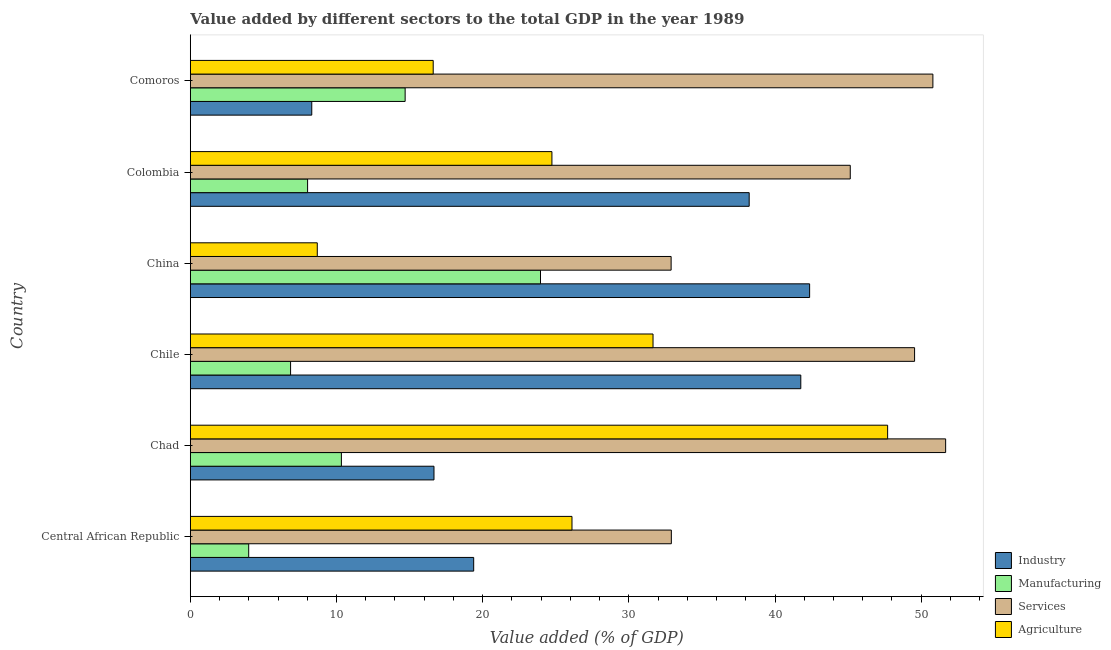How many different coloured bars are there?
Make the answer very short. 4. How many bars are there on the 4th tick from the top?
Offer a terse response. 4. What is the label of the 6th group of bars from the top?
Give a very brief answer. Central African Republic. What is the value added by manufacturing sector in China?
Give a very brief answer. 23.96. Across all countries, what is the maximum value added by services sector?
Keep it short and to the point. 51.67. Across all countries, what is the minimum value added by manufacturing sector?
Offer a very short reply. 4. In which country was the value added by services sector maximum?
Keep it short and to the point. Chad. In which country was the value added by industrial sector minimum?
Offer a terse response. Comoros. What is the total value added by industrial sector in the graph?
Offer a very short reply. 166.73. What is the difference between the value added by manufacturing sector in Chad and that in Chile?
Give a very brief answer. 3.48. What is the difference between the value added by industrial sector in Central African Republic and the value added by agricultural sector in Chad?
Make the answer very short. -28.32. What is the average value added by manufacturing sector per country?
Offer a terse response. 11.31. What is the difference between the value added by manufacturing sector and value added by industrial sector in Colombia?
Provide a short and direct response. -30.21. What is the ratio of the value added by manufacturing sector in Chile to that in China?
Ensure brevity in your answer.  0.29. Is the value added by services sector in Chile less than that in China?
Offer a terse response. No. What is the difference between the highest and the second highest value added by agricultural sector?
Give a very brief answer. 16.05. What is the difference between the highest and the lowest value added by industrial sector?
Make the answer very short. 34.06. In how many countries, is the value added by industrial sector greater than the average value added by industrial sector taken over all countries?
Offer a very short reply. 3. Is the sum of the value added by manufacturing sector in China and Colombia greater than the maximum value added by agricultural sector across all countries?
Make the answer very short. No. What does the 2nd bar from the top in Chile represents?
Your response must be concise. Services. What does the 2nd bar from the bottom in Chad represents?
Offer a terse response. Manufacturing. Is it the case that in every country, the sum of the value added by industrial sector and value added by manufacturing sector is greater than the value added by services sector?
Make the answer very short. No. What is the difference between two consecutive major ticks on the X-axis?
Your answer should be compact. 10. Are the values on the major ticks of X-axis written in scientific E-notation?
Your response must be concise. No. Does the graph contain grids?
Your answer should be compact. No. Where does the legend appear in the graph?
Ensure brevity in your answer.  Bottom right. What is the title of the graph?
Provide a succinct answer. Value added by different sectors to the total GDP in the year 1989. Does "Services" appear as one of the legend labels in the graph?
Offer a very short reply. Yes. What is the label or title of the X-axis?
Give a very brief answer. Value added (% of GDP). What is the label or title of the Y-axis?
Ensure brevity in your answer.  Country. What is the Value added (% of GDP) of Industry in Central African Republic?
Make the answer very short. 19.39. What is the Value added (% of GDP) of Manufacturing in Central African Republic?
Provide a short and direct response. 4. What is the Value added (% of GDP) in Services in Central African Republic?
Provide a short and direct response. 32.91. What is the Value added (% of GDP) of Agriculture in Central African Republic?
Offer a terse response. 26.11. What is the Value added (% of GDP) in Industry in Chad?
Your response must be concise. 16.67. What is the Value added (% of GDP) of Manufacturing in Chad?
Offer a terse response. 10.34. What is the Value added (% of GDP) in Services in Chad?
Offer a very short reply. 51.67. What is the Value added (% of GDP) of Agriculture in Chad?
Your answer should be very brief. 47.7. What is the Value added (% of GDP) in Industry in Chile?
Your answer should be compact. 41.76. What is the Value added (% of GDP) of Manufacturing in Chile?
Your answer should be compact. 6.86. What is the Value added (% of GDP) of Services in Chile?
Ensure brevity in your answer.  49.55. What is the Value added (% of GDP) in Agriculture in Chile?
Ensure brevity in your answer.  31.66. What is the Value added (% of GDP) in Industry in China?
Provide a succinct answer. 42.37. What is the Value added (% of GDP) of Manufacturing in China?
Your answer should be compact. 23.96. What is the Value added (% of GDP) in Services in China?
Ensure brevity in your answer.  32.89. What is the Value added (% of GDP) of Agriculture in China?
Provide a succinct answer. 8.69. What is the Value added (% of GDP) of Industry in Colombia?
Offer a terse response. 38.23. What is the Value added (% of GDP) in Manufacturing in Colombia?
Give a very brief answer. 8.02. What is the Value added (% of GDP) in Services in Colombia?
Offer a terse response. 45.15. What is the Value added (% of GDP) of Agriculture in Colombia?
Your response must be concise. 24.74. What is the Value added (% of GDP) in Industry in Comoros?
Provide a short and direct response. 8.31. What is the Value added (% of GDP) of Manufacturing in Comoros?
Provide a short and direct response. 14.7. What is the Value added (% of GDP) in Services in Comoros?
Offer a terse response. 50.8. What is the Value added (% of GDP) in Agriculture in Comoros?
Make the answer very short. 16.62. Across all countries, what is the maximum Value added (% of GDP) of Industry?
Make the answer very short. 42.37. Across all countries, what is the maximum Value added (% of GDP) of Manufacturing?
Your answer should be compact. 23.96. Across all countries, what is the maximum Value added (% of GDP) of Services?
Provide a succinct answer. 51.67. Across all countries, what is the maximum Value added (% of GDP) in Agriculture?
Make the answer very short. 47.7. Across all countries, what is the minimum Value added (% of GDP) of Industry?
Offer a very short reply. 8.31. Across all countries, what is the minimum Value added (% of GDP) of Manufacturing?
Offer a very short reply. 4. Across all countries, what is the minimum Value added (% of GDP) of Services?
Your answer should be compact. 32.89. Across all countries, what is the minimum Value added (% of GDP) of Agriculture?
Offer a very short reply. 8.69. What is the total Value added (% of GDP) of Industry in the graph?
Provide a succinct answer. 166.73. What is the total Value added (% of GDP) of Manufacturing in the graph?
Offer a terse response. 67.87. What is the total Value added (% of GDP) of Services in the graph?
Your answer should be very brief. 262.97. What is the total Value added (% of GDP) in Agriculture in the graph?
Provide a succinct answer. 155.52. What is the difference between the Value added (% of GDP) of Industry in Central African Republic and that in Chad?
Make the answer very short. 2.72. What is the difference between the Value added (% of GDP) of Manufacturing in Central African Republic and that in Chad?
Ensure brevity in your answer.  -6.34. What is the difference between the Value added (% of GDP) in Services in Central African Republic and that in Chad?
Provide a short and direct response. -18.76. What is the difference between the Value added (% of GDP) in Agriculture in Central African Republic and that in Chad?
Your response must be concise. -21.59. What is the difference between the Value added (% of GDP) of Industry in Central African Republic and that in Chile?
Offer a very short reply. -22.38. What is the difference between the Value added (% of GDP) in Manufacturing in Central African Republic and that in Chile?
Give a very brief answer. -2.87. What is the difference between the Value added (% of GDP) of Services in Central African Republic and that in Chile?
Give a very brief answer. -16.64. What is the difference between the Value added (% of GDP) of Agriculture in Central African Republic and that in Chile?
Offer a very short reply. -5.54. What is the difference between the Value added (% of GDP) in Industry in Central African Republic and that in China?
Keep it short and to the point. -22.98. What is the difference between the Value added (% of GDP) of Manufacturing in Central African Republic and that in China?
Your answer should be very brief. -19.96. What is the difference between the Value added (% of GDP) of Services in Central African Republic and that in China?
Offer a very short reply. 0.02. What is the difference between the Value added (% of GDP) in Agriculture in Central African Republic and that in China?
Provide a short and direct response. 17.42. What is the difference between the Value added (% of GDP) of Industry in Central African Republic and that in Colombia?
Offer a very short reply. -18.85. What is the difference between the Value added (% of GDP) in Manufacturing in Central African Republic and that in Colombia?
Make the answer very short. -4.03. What is the difference between the Value added (% of GDP) in Services in Central African Republic and that in Colombia?
Give a very brief answer. -12.24. What is the difference between the Value added (% of GDP) in Agriculture in Central African Republic and that in Colombia?
Your answer should be compact. 1.37. What is the difference between the Value added (% of GDP) of Industry in Central African Republic and that in Comoros?
Your answer should be very brief. 11.08. What is the difference between the Value added (% of GDP) in Manufacturing in Central African Republic and that in Comoros?
Your answer should be very brief. -10.7. What is the difference between the Value added (% of GDP) in Services in Central African Republic and that in Comoros?
Your answer should be very brief. -17.89. What is the difference between the Value added (% of GDP) of Agriculture in Central African Republic and that in Comoros?
Your response must be concise. 9.49. What is the difference between the Value added (% of GDP) in Industry in Chad and that in Chile?
Provide a succinct answer. -25.09. What is the difference between the Value added (% of GDP) of Manufacturing in Chad and that in Chile?
Offer a very short reply. 3.48. What is the difference between the Value added (% of GDP) in Services in Chad and that in Chile?
Provide a succinct answer. 2.13. What is the difference between the Value added (% of GDP) in Agriculture in Chad and that in Chile?
Give a very brief answer. 16.05. What is the difference between the Value added (% of GDP) of Industry in Chad and that in China?
Make the answer very short. -25.7. What is the difference between the Value added (% of GDP) in Manufacturing in Chad and that in China?
Give a very brief answer. -13.62. What is the difference between the Value added (% of GDP) in Services in Chad and that in China?
Ensure brevity in your answer.  18.78. What is the difference between the Value added (% of GDP) of Agriculture in Chad and that in China?
Provide a short and direct response. 39.02. What is the difference between the Value added (% of GDP) in Industry in Chad and that in Colombia?
Give a very brief answer. -21.56. What is the difference between the Value added (% of GDP) in Manufacturing in Chad and that in Colombia?
Your answer should be very brief. 2.31. What is the difference between the Value added (% of GDP) in Services in Chad and that in Colombia?
Your answer should be very brief. 6.53. What is the difference between the Value added (% of GDP) in Agriculture in Chad and that in Colombia?
Provide a short and direct response. 22.96. What is the difference between the Value added (% of GDP) in Industry in Chad and that in Comoros?
Make the answer very short. 8.36. What is the difference between the Value added (% of GDP) in Manufacturing in Chad and that in Comoros?
Give a very brief answer. -4.36. What is the difference between the Value added (% of GDP) in Services in Chad and that in Comoros?
Give a very brief answer. 0.87. What is the difference between the Value added (% of GDP) in Agriculture in Chad and that in Comoros?
Offer a terse response. 31.09. What is the difference between the Value added (% of GDP) of Industry in Chile and that in China?
Your answer should be compact. -0.6. What is the difference between the Value added (% of GDP) in Manufacturing in Chile and that in China?
Provide a short and direct response. -17.1. What is the difference between the Value added (% of GDP) of Services in Chile and that in China?
Make the answer very short. 16.65. What is the difference between the Value added (% of GDP) in Agriculture in Chile and that in China?
Make the answer very short. 22.97. What is the difference between the Value added (% of GDP) of Industry in Chile and that in Colombia?
Provide a succinct answer. 3.53. What is the difference between the Value added (% of GDP) in Manufacturing in Chile and that in Colombia?
Offer a terse response. -1.16. What is the difference between the Value added (% of GDP) in Services in Chile and that in Colombia?
Make the answer very short. 4.4. What is the difference between the Value added (% of GDP) of Agriculture in Chile and that in Colombia?
Offer a terse response. 6.92. What is the difference between the Value added (% of GDP) in Industry in Chile and that in Comoros?
Give a very brief answer. 33.45. What is the difference between the Value added (% of GDP) of Manufacturing in Chile and that in Comoros?
Your answer should be compact. -7.84. What is the difference between the Value added (% of GDP) of Services in Chile and that in Comoros?
Give a very brief answer. -1.25. What is the difference between the Value added (% of GDP) in Agriculture in Chile and that in Comoros?
Provide a succinct answer. 15.04. What is the difference between the Value added (% of GDP) in Industry in China and that in Colombia?
Your answer should be very brief. 4.13. What is the difference between the Value added (% of GDP) in Manufacturing in China and that in Colombia?
Provide a succinct answer. 15.93. What is the difference between the Value added (% of GDP) in Services in China and that in Colombia?
Offer a terse response. -12.26. What is the difference between the Value added (% of GDP) of Agriculture in China and that in Colombia?
Keep it short and to the point. -16.05. What is the difference between the Value added (% of GDP) in Industry in China and that in Comoros?
Offer a very short reply. 34.06. What is the difference between the Value added (% of GDP) in Manufacturing in China and that in Comoros?
Your response must be concise. 9.26. What is the difference between the Value added (% of GDP) of Services in China and that in Comoros?
Offer a very short reply. -17.91. What is the difference between the Value added (% of GDP) of Agriculture in China and that in Comoros?
Offer a terse response. -7.93. What is the difference between the Value added (% of GDP) in Industry in Colombia and that in Comoros?
Offer a terse response. 29.92. What is the difference between the Value added (% of GDP) in Manufacturing in Colombia and that in Comoros?
Provide a succinct answer. -6.67. What is the difference between the Value added (% of GDP) in Services in Colombia and that in Comoros?
Offer a very short reply. -5.65. What is the difference between the Value added (% of GDP) in Agriculture in Colombia and that in Comoros?
Provide a short and direct response. 8.12. What is the difference between the Value added (% of GDP) of Industry in Central African Republic and the Value added (% of GDP) of Manufacturing in Chad?
Keep it short and to the point. 9.05. What is the difference between the Value added (% of GDP) of Industry in Central African Republic and the Value added (% of GDP) of Services in Chad?
Ensure brevity in your answer.  -32.29. What is the difference between the Value added (% of GDP) of Industry in Central African Republic and the Value added (% of GDP) of Agriculture in Chad?
Your response must be concise. -28.32. What is the difference between the Value added (% of GDP) of Manufacturing in Central African Republic and the Value added (% of GDP) of Services in Chad?
Offer a terse response. -47.68. What is the difference between the Value added (% of GDP) of Manufacturing in Central African Republic and the Value added (% of GDP) of Agriculture in Chad?
Provide a succinct answer. -43.71. What is the difference between the Value added (% of GDP) in Services in Central African Republic and the Value added (% of GDP) in Agriculture in Chad?
Your response must be concise. -14.8. What is the difference between the Value added (% of GDP) in Industry in Central African Republic and the Value added (% of GDP) in Manufacturing in Chile?
Keep it short and to the point. 12.53. What is the difference between the Value added (% of GDP) in Industry in Central African Republic and the Value added (% of GDP) in Services in Chile?
Keep it short and to the point. -30.16. What is the difference between the Value added (% of GDP) in Industry in Central African Republic and the Value added (% of GDP) in Agriculture in Chile?
Keep it short and to the point. -12.27. What is the difference between the Value added (% of GDP) in Manufacturing in Central African Republic and the Value added (% of GDP) in Services in Chile?
Provide a succinct answer. -45.55. What is the difference between the Value added (% of GDP) in Manufacturing in Central African Republic and the Value added (% of GDP) in Agriculture in Chile?
Your answer should be very brief. -27.66. What is the difference between the Value added (% of GDP) in Services in Central African Republic and the Value added (% of GDP) in Agriculture in Chile?
Ensure brevity in your answer.  1.25. What is the difference between the Value added (% of GDP) in Industry in Central African Republic and the Value added (% of GDP) in Manufacturing in China?
Ensure brevity in your answer.  -4.57. What is the difference between the Value added (% of GDP) of Industry in Central African Republic and the Value added (% of GDP) of Services in China?
Provide a short and direct response. -13.51. What is the difference between the Value added (% of GDP) in Industry in Central African Republic and the Value added (% of GDP) in Agriculture in China?
Keep it short and to the point. 10.7. What is the difference between the Value added (% of GDP) in Manufacturing in Central African Republic and the Value added (% of GDP) in Services in China?
Your response must be concise. -28.9. What is the difference between the Value added (% of GDP) of Manufacturing in Central African Republic and the Value added (% of GDP) of Agriculture in China?
Provide a succinct answer. -4.69. What is the difference between the Value added (% of GDP) of Services in Central African Republic and the Value added (% of GDP) of Agriculture in China?
Provide a succinct answer. 24.22. What is the difference between the Value added (% of GDP) in Industry in Central African Republic and the Value added (% of GDP) in Manufacturing in Colombia?
Offer a terse response. 11.36. What is the difference between the Value added (% of GDP) in Industry in Central African Republic and the Value added (% of GDP) in Services in Colombia?
Give a very brief answer. -25.76. What is the difference between the Value added (% of GDP) of Industry in Central African Republic and the Value added (% of GDP) of Agriculture in Colombia?
Offer a very short reply. -5.35. What is the difference between the Value added (% of GDP) in Manufacturing in Central African Republic and the Value added (% of GDP) in Services in Colombia?
Provide a succinct answer. -41.15. What is the difference between the Value added (% of GDP) of Manufacturing in Central African Republic and the Value added (% of GDP) of Agriculture in Colombia?
Your answer should be compact. -20.74. What is the difference between the Value added (% of GDP) in Services in Central African Republic and the Value added (% of GDP) in Agriculture in Colombia?
Your response must be concise. 8.17. What is the difference between the Value added (% of GDP) of Industry in Central African Republic and the Value added (% of GDP) of Manufacturing in Comoros?
Give a very brief answer. 4.69. What is the difference between the Value added (% of GDP) in Industry in Central African Republic and the Value added (% of GDP) in Services in Comoros?
Ensure brevity in your answer.  -31.41. What is the difference between the Value added (% of GDP) of Industry in Central African Republic and the Value added (% of GDP) of Agriculture in Comoros?
Your answer should be very brief. 2.77. What is the difference between the Value added (% of GDP) in Manufacturing in Central African Republic and the Value added (% of GDP) in Services in Comoros?
Provide a short and direct response. -46.81. What is the difference between the Value added (% of GDP) of Manufacturing in Central African Republic and the Value added (% of GDP) of Agriculture in Comoros?
Your answer should be compact. -12.62. What is the difference between the Value added (% of GDP) in Services in Central African Republic and the Value added (% of GDP) in Agriculture in Comoros?
Ensure brevity in your answer.  16.29. What is the difference between the Value added (% of GDP) of Industry in Chad and the Value added (% of GDP) of Manufacturing in Chile?
Offer a terse response. 9.81. What is the difference between the Value added (% of GDP) of Industry in Chad and the Value added (% of GDP) of Services in Chile?
Make the answer very short. -32.88. What is the difference between the Value added (% of GDP) of Industry in Chad and the Value added (% of GDP) of Agriculture in Chile?
Offer a very short reply. -14.98. What is the difference between the Value added (% of GDP) of Manufacturing in Chad and the Value added (% of GDP) of Services in Chile?
Make the answer very short. -39.21. What is the difference between the Value added (% of GDP) in Manufacturing in Chad and the Value added (% of GDP) in Agriculture in Chile?
Make the answer very short. -21.32. What is the difference between the Value added (% of GDP) in Services in Chad and the Value added (% of GDP) in Agriculture in Chile?
Your answer should be very brief. 20.02. What is the difference between the Value added (% of GDP) of Industry in Chad and the Value added (% of GDP) of Manufacturing in China?
Offer a terse response. -7.29. What is the difference between the Value added (% of GDP) in Industry in Chad and the Value added (% of GDP) in Services in China?
Your answer should be very brief. -16.22. What is the difference between the Value added (% of GDP) in Industry in Chad and the Value added (% of GDP) in Agriculture in China?
Give a very brief answer. 7.98. What is the difference between the Value added (% of GDP) in Manufacturing in Chad and the Value added (% of GDP) in Services in China?
Provide a succinct answer. -22.56. What is the difference between the Value added (% of GDP) in Manufacturing in Chad and the Value added (% of GDP) in Agriculture in China?
Offer a very short reply. 1.65. What is the difference between the Value added (% of GDP) of Services in Chad and the Value added (% of GDP) of Agriculture in China?
Give a very brief answer. 42.99. What is the difference between the Value added (% of GDP) of Industry in Chad and the Value added (% of GDP) of Manufacturing in Colombia?
Provide a succinct answer. 8.65. What is the difference between the Value added (% of GDP) in Industry in Chad and the Value added (% of GDP) in Services in Colombia?
Provide a succinct answer. -28.48. What is the difference between the Value added (% of GDP) of Industry in Chad and the Value added (% of GDP) of Agriculture in Colombia?
Your answer should be very brief. -8.07. What is the difference between the Value added (% of GDP) in Manufacturing in Chad and the Value added (% of GDP) in Services in Colombia?
Your answer should be very brief. -34.81. What is the difference between the Value added (% of GDP) of Manufacturing in Chad and the Value added (% of GDP) of Agriculture in Colombia?
Provide a short and direct response. -14.4. What is the difference between the Value added (% of GDP) in Services in Chad and the Value added (% of GDP) in Agriculture in Colombia?
Keep it short and to the point. 26.93. What is the difference between the Value added (% of GDP) in Industry in Chad and the Value added (% of GDP) in Manufacturing in Comoros?
Offer a very short reply. 1.97. What is the difference between the Value added (% of GDP) of Industry in Chad and the Value added (% of GDP) of Services in Comoros?
Your answer should be very brief. -34.13. What is the difference between the Value added (% of GDP) of Industry in Chad and the Value added (% of GDP) of Agriculture in Comoros?
Your response must be concise. 0.05. What is the difference between the Value added (% of GDP) in Manufacturing in Chad and the Value added (% of GDP) in Services in Comoros?
Ensure brevity in your answer.  -40.46. What is the difference between the Value added (% of GDP) of Manufacturing in Chad and the Value added (% of GDP) of Agriculture in Comoros?
Make the answer very short. -6.28. What is the difference between the Value added (% of GDP) in Services in Chad and the Value added (% of GDP) in Agriculture in Comoros?
Make the answer very short. 35.06. What is the difference between the Value added (% of GDP) in Industry in Chile and the Value added (% of GDP) in Manufacturing in China?
Ensure brevity in your answer.  17.81. What is the difference between the Value added (% of GDP) of Industry in Chile and the Value added (% of GDP) of Services in China?
Make the answer very short. 8.87. What is the difference between the Value added (% of GDP) in Industry in Chile and the Value added (% of GDP) in Agriculture in China?
Offer a terse response. 33.08. What is the difference between the Value added (% of GDP) of Manufacturing in Chile and the Value added (% of GDP) of Services in China?
Your answer should be compact. -26.03. What is the difference between the Value added (% of GDP) in Manufacturing in Chile and the Value added (% of GDP) in Agriculture in China?
Provide a short and direct response. -1.83. What is the difference between the Value added (% of GDP) of Services in Chile and the Value added (% of GDP) of Agriculture in China?
Keep it short and to the point. 40.86. What is the difference between the Value added (% of GDP) of Industry in Chile and the Value added (% of GDP) of Manufacturing in Colombia?
Make the answer very short. 33.74. What is the difference between the Value added (% of GDP) of Industry in Chile and the Value added (% of GDP) of Services in Colombia?
Offer a terse response. -3.38. What is the difference between the Value added (% of GDP) of Industry in Chile and the Value added (% of GDP) of Agriculture in Colombia?
Keep it short and to the point. 17.03. What is the difference between the Value added (% of GDP) in Manufacturing in Chile and the Value added (% of GDP) in Services in Colombia?
Ensure brevity in your answer.  -38.29. What is the difference between the Value added (% of GDP) of Manufacturing in Chile and the Value added (% of GDP) of Agriculture in Colombia?
Your answer should be very brief. -17.88. What is the difference between the Value added (% of GDP) in Services in Chile and the Value added (% of GDP) in Agriculture in Colombia?
Offer a very short reply. 24.81. What is the difference between the Value added (% of GDP) in Industry in Chile and the Value added (% of GDP) in Manufacturing in Comoros?
Your response must be concise. 27.07. What is the difference between the Value added (% of GDP) in Industry in Chile and the Value added (% of GDP) in Services in Comoros?
Ensure brevity in your answer.  -9.04. What is the difference between the Value added (% of GDP) of Industry in Chile and the Value added (% of GDP) of Agriculture in Comoros?
Provide a short and direct response. 25.15. What is the difference between the Value added (% of GDP) in Manufacturing in Chile and the Value added (% of GDP) in Services in Comoros?
Keep it short and to the point. -43.94. What is the difference between the Value added (% of GDP) of Manufacturing in Chile and the Value added (% of GDP) of Agriculture in Comoros?
Provide a short and direct response. -9.76. What is the difference between the Value added (% of GDP) of Services in Chile and the Value added (% of GDP) of Agriculture in Comoros?
Offer a very short reply. 32.93. What is the difference between the Value added (% of GDP) of Industry in China and the Value added (% of GDP) of Manufacturing in Colombia?
Ensure brevity in your answer.  34.34. What is the difference between the Value added (% of GDP) in Industry in China and the Value added (% of GDP) in Services in Colombia?
Offer a terse response. -2.78. What is the difference between the Value added (% of GDP) in Industry in China and the Value added (% of GDP) in Agriculture in Colombia?
Provide a succinct answer. 17.63. What is the difference between the Value added (% of GDP) of Manufacturing in China and the Value added (% of GDP) of Services in Colombia?
Your response must be concise. -21.19. What is the difference between the Value added (% of GDP) in Manufacturing in China and the Value added (% of GDP) in Agriculture in Colombia?
Provide a succinct answer. -0.78. What is the difference between the Value added (% of GDP) in Services in China and the Value added (% of GDP) in Agriculture in Colombia?
Your response must be concise. 8.15. What is the difference between the Value added (% of GDP) of Industry in China and the Value added (% of GDP) of Manufacturing in Comoros?
Make the answer very short. 27.67. What is the difference between the Value added (% of GDP) in Industry in China and the Value added (% of GDP) in Services in Comoros?
Provide a short and direct response. -8.43. What is the difference between the Value added (% of GDP) in Industry in China and the Value added (% of GDP) in Agriculture in Comoros?
Your response must be concise. 25.75. What is the difference between the Value added (% of GDP) in Manufacturing in China and the Value added (% of GDP) in Services in Comoros?
Ensure brevity in your answer.  -26.84. What is the difference between the Value added (% of GDP) of Manufacturing in China and the Value added (% of GDP) of Agriculture in Comoros?
Your answer should be compact. 7.34. What is the difference between the Value added (% of GDP) in Services in China and the Value added (% of GDP) in Agriculture in Comoros?
Give a very brief answer. 16.28. What is the difference between the Value added (% of GDP) in Industry in Colombia and the Value added (% of GDP) in Manufacturing in Comoros?
Give a very brief answer. 23.54. What is the difference between the Value added (% of GDP) in Industry in Colombia and the Value added (% of GDP) in Services in Comoros?
Ensure brevity in your answer.  -12.57. What is the difference between the Value added (% of GDP) in Industry in Colombia and the Value added (% of GDP) in Agriculture in Comoros?
Your answer should be compact. 21.62. What is the difference between the Value added (% of GDP) of Manufacturing in Colombia and the Value added (% of GDP) of Services in Comoros?
Offer a terse response. -42.78. What is the difference between the Value added (% of GDP) of Manufacturing in Colombia and the Value added (% of GDP) of Agriculture in Comoros?
Your answer should be compact. -8.59. What is the difference between the Value added (% of GDP) in Services in Colombia and the Value added (% of GDP) in Agriculture in Comoros?
Provide a succinct answer. 28.53. What is the average Value added (% of GDP) of Industry per country?
Offer a terse response. 27.79. What is the average Value added (% of GDP) in Manufacturing per country?
Provide a short and direct response. 11.31. What is the average Value added (% of GDP) of Services per country?
Give a very brief answer. 43.83. What is the average Value added (% of GDP) of Agriculture per country?
Your answer should be very brief. 25.92. What is the difference between the Value added (% of GDP) of Industry and Value added (% of GDP) of Manufacturing in Central African Republic?
Your answer should be compact. 15.39. What is the difference between the Value added (% of GDP) in Industry and Value added (% of GDP) in Services in Central African Republic?
Give a very brief answer. -13.52. What is the difference between the Value added (% of GDP) in Industry and Value added (% of GDP) in Agriculture in Central African Republic?
Ensure brevity in your answer.  -6.72. What is the difference between the Value added (% of GDP) in Manufacturing and Value added (% of GDP) in Services in Central African Republic?
Give a very brief answer. -28.91. What is the difference between the Value added (% of GDP) in Manufacturing and Value added (% of GDP) in Agriculture in Central African Republic?
Make the answer very short. -22.12. What is the difference between the Value added (% of GDP) of Services and Value added (% of GDP) of Agriculture in Central African Republic?
Your answer should be very brief. 6.8. What is the difference between the Value added (% of GDP) of Industry and Value added (% of GDP) of Manufacturing in Chad?
Your answer should be very brief. 6.33. What is the difference between the Value added (% of GDP) in Industry and Value added (% of GDP) in Services in Chad?
Keep it short and to the point. -35. What is the difference between the Value added (% of GDP) of Industry and Value added (% of GDP) of Agriculture in Chad?
Your response must be concise. -31.03. What is the difference between the Value added (% of GDP) in Manufacturing and Value added (% of GDP) in Services in Chad?
Give a very brief answer. -41.34. What is the difference between the Value added (% of GDP) of Manufacturing and Value added (% of GDP) of Agriculture in Chad?
Give a very brief answer. -37.37. What is the difference between the Value added (% of GDP) of Services and Value added (% of GDP) of Agriculture in Chad?
Ensure brevity in your answer.  3.97. What is the difference between the Value added (% of GDP) in Industry and Value added (% of GDP) in Manufacturing in Chile?
Your response must be concise. 34.9. What is the difference between the Value added (% of GDP) in Industry and Value added (% of GDP) in Services in Chile?
Give a very brief answer. -7.78. What is the difference between the Value added (% of GDP) in Industry and Value added (% of GDP) in Agriculture in Chile?
Your answer should be very brief. 10.11. What is the difference between the Value added (% of GDP) in Manufacturing and Value added (% of GDP) in Services in Chile?
Your answer should be very brief. -42.69. What is the difference between the Value added (% of GDP) of Manufacturing and Value added (% of GDP) of Agriculture in Chile?
Ensure brevity in your answer.  -24.79. What is the difference between the Value added (% of GDP) of Services and Value added (% of GDP) of Agriculture in Chile?
Offer a very short reply. 17.89. What is the difference between the Value added (% of GDP) in Industry and Value added (% of GDP) in Manufacturing in China?
Provide a succinct answer. 18.41. What is the difference between the Value added (% of GDP) in Industry and Value added (% of GDP) in Services in China?
Your answer should be very brief. 9.47. What is the difference between the Value added (% of GDP) in Industry and Value added (% of GDP) in Agriculture in China?
Offer a very short reply. 33.68. What is the difference between the Value added (% of GDP) of Manufacturing and Value added (% of GDP) of Services in China?
Make the answer very short. -8.94. What is the difference between the Value added (% of GDP) in Manufacturing and Value added (% of GDP) in Agriculture in China?
Give a very brief answer. 15.27. What is the difference between the Value added (% of GDP) in Services and Value added (% of GDP) in Agriculture in China?
Keep it short and to the point. 24.21. What is the difference between the Value added (% of GDP) in Industry and Value added (% of GDP) in Manufacturing in Colombia?
Ensure brevity in your answer.  30.21. What is the difference between the Value added (% of GDP) in Industry and Value added (% of GDP) in Services in Colombia?
Your answer should be very brief. -6.91. What is the difference between the Value added (% of GDP) of Industry and Value added (% of GDP) of Agriculture in Colombia?
Make the answer very short. 13.49. What is the difference between the Value added (% of GDP) of Manufacturing and Value added (% of GDP) of Services in Colombia?
Your response must be concise. -37.12. What is the difference between the Value added (% of GDP) in Manufacturing and Value added (% of GDP) in Agriculture in Colombia?
Make the answer very short. -16.72. What is the difference between the Value added (% of GDP) in Services and Value added (% of GDP) in Agriculture in Colombia?
Give a very brief answer. 20.41. What is the difference between the Value added (% of GDP) in Industry and Value added (% of GDP) in Manufacturing in Comoros?
Give a very brief answer. -6.39. What is the difference between the Value added (% of GDP) in Industry and Value added (% of GDP) in Services in Comoros?
Your answer should be compact. -42.49. What is the difference between the Value added (% of GDP) of Industry and Value added (% of GDP) of Agriculture in Comoros?
Keep it short and to the point. -8.31. What is the difference between the Value added (% of GDP) in Manufacturing and Value added (% of GDP) in Services in Comoros?
Offer a very short reply. -36.1. What is the difference between the Value added (% of GDP) in Manufacturing and Value added (% of GDP) in Agriculture in Comoros?
Offer a very short reply. -1.92. What is the difference between the Value added (% of GDP) of Services and Value added (% of GDP) of Agriculture in Comoros?
Keep it short and to the point. 34.18. What is the ratio of the Value added (% of GDP) in Industry in Central African Republic to that in Chad?
Your answer should be very brief. 1.16. What is the ratio of the Value added (% of GDP) in Manufacturing in Central African Republic to that in Chad?
Ensure brevity in your answer.  0.39. What is the ratio of the Value added (% of GDP) of Services in Central African Republic to that in Chad?
Your response must be concise. 0.64. What is the ratio of the Value added (% of GDP) of Agriculture in Central African Republic to that in Chad?
Offer a very short reply. 0.55. What is the ratio of the Value added (% of GDP) of Industry in Central African Republic to that in Chile?
Ensure brevity in your answer.  0.46. What is the ratio of the Value added (% of GDP) of Manufacturing in Central African Republic to that in Chile?
Ensure brevity in your answer.  0.58. What is the ratio of the Value added (% of GDP) of Services in Central African Republic to that in Chile?
Provide a succinct answer. 0.66. What is the ratio of the Value added (% of GDP) in Agriculture in Central African Republic to that in Chile?
Offer a terse response. 0.82. What is the ratio of the Value added (% of GDP) of Industry in Central African Republic to that in China?
Your answer should be very brief. 0.46. What is the ratio of the Value added (% of GDP) of Manufacturing in Central African Republic to that in China?
Your answer should be compact. 0.17. What is the ratio of the Value added (% of GDP) of Services in Central African Republic to that in China?
Provide a short and direct response. 1. What is the ratio of the Value added (% of GDP) of Agriculture in Central African Republic to that in China?
Provide a short and direct response. 3.01. What is the ratio of the Value added (% of GDP) of Industry in Central African Republic to that in Colombia?
Your answer should be very brief. 0.51. What is the ratio of the Value added (% of GDP) of Manufacturing in Central African Republic to that in Colombia?
Offer a very short reply. 0.5. What is the ratio of the Value added (% of GDP) in Services in Central African Republic to that in Colombia?
Ensure brevity in your answer.  0.73. What is the ratio of the Value added (% of GDP) of Agriculture in Central African Republic to that in Colombia?
Keep it short and to the point. 1.06. What is the ratio of the Value added (% of GDP) of Industry in Central African Republic to that in Comoros?
Your answer should be very brief. 2.33. What is the ratio of the Value added (% of GDP) of Manufacturing in Central African Republic to that in Comoros?
Offer a terse response. 0.27. What is the ratio of the Value added (% of GDP) in Services in Central African Republic to that in Comoros?
Ensure brevity in your answer.  0.65. What is the ratio of the Value added (% of GDP) of Agriculture in Central African Republic to that in Comoros?
Provide a short and direct response. 1.57. What is the ratio of the Value added (% of GDP) in Industry in Chad to that in Chile?
Keep it short and to the point. 0.4. What is the ratio of the Value added (% of GDP) in Manufacturing in Chad to that in Chile?
Make the answer very short. 1.51. What is the ratio of the Value added (% of GDP) of Services in Chad to that in Chile?
Make the answer very short. 1.04. What is the ratio of the Value added (% of GDP) of Agriculture in Chad to that in Chile?
Give a very brief answer. 1.51. What is the ratio of the Value added (% of GDP) in Industry in Chad to that in China?
Provide a succinct answer. 0.39. What is the ratio of the Value added (% of GDP) in Manufacturing in Chad to that in China?
Offer a terse response. 0.43. What is the ratio of the Value added (% of GDP) of Services in Chad to that in China?
Provide a succinct answer. 1.57. What is the ratio of the Value added (% of GDP) of Agriculture in Chad to that in China?
Offer a very short reply. 5.49. What is the ratio of the Value added (% of GDP) in Industry in Chad to that in Colombia?
Give a very brief answer. 0.44. What is the ratio of the Value added (% of GDP) in Manufacturing in Chad to that in Colombia?
Give a very brief answer. 1.29. What is the ratio of the Value added (% of GDP) of Services in Chad to that in Colombia?
Your answer should be compact. 1.14. What is the ratio of the Value added (% of GDP) of Agriculture in Chad to that in Colombia?
Offer a very short reply. 1.93. What is the ratio of the Value added (% of GDP) of Industry in Chad to that in Comoros?
Provide a short and direct response. 2.01. What is the ratio of the Value added (% of GDP) of Manufacturing in Chad to that in Comoros?
Make the answer very short. 0.7. What is the ratio of the Value added (% of GDP) in Services in Chad to that in Comoros?
Your answer should be very brief. 1.02. What is the ratio of the Value added (% of GDP) of Agriculture in Chad to that in Comoros?
Your response must be concise. 2.87. What is the ratio of the Value added (% of GDP) of Industry in Chile to that in China?
Offer a very short reply. 0.99. What is the ratio of the Value added (% of GDP) in Manufacturing in Chile to that in China?
Ensure brevity in your answer.  0.29. What is the ratio of the Value added (% of GDP) of Services in Chile to that in China?
Keep it short and to the point. 1.51. What is the ratio of the Value added (% of GDP) of Agriculture in Chile to that in China?
Give a very brief answer. 3.64. What is the ratio of the Value added (% of GDP) of Industry in Chile to that in Colombia?
Offer a very short reply. 1.09. What is the ratio of the Value added (% of GDP) of Manufacturing in Chile to that in Colombia?
Your response must be concise. 0.85. What is the ratio of the Value added (% of GDP) of Services in Chile to that in Colombia?
Your answer should be compact. 1.1. What is the ratio of the Value added (% of GDP) of Agriculture in Chile to that in Colombia?
Your answer should be compact. 1.28. What is the ratio of the Value added (% of GDP) in Industry in Chile to that in Comoros?
Your answer should be compact. 5.03. What is the ratio of the Value added (% of GDP) in Manufacturing in Chile to that in Comoros?
Ensure brevity in your answer.  0.47. What is the ratio of the Value added (% of GDP) in Services in Chile to that in Comoros?
Give a very brief answer. 0.98. What is the ratio of the Value added (% of GDP) in Agriculture in Chile to that in Comoros?
Give a very brief answer. 1.9. What is the ratio of the Value added (% of GDP) in Industry in China to that in Colombia?
Ensure brevity in your answer.  1.11. What is the ratio of the Value added (% of GDP) of Manufacturing in China to that in Colombia?
Offer a terse response. 2.99. What is the ratio of the Value added (% of GDP) in Services in China to that in Colombia?
Offer a very short reply. 0.73. What is the ratio of the Value added (% of GDP) in Agriculture in China to that in Colombia?
Offer a very short reply. 0.35. What is the ratio of the Value added (% of GDP) in Industry in China to that in Comoros?
Provide a succinct answer. 5.1. What is the ratio of the Value added (% of GDP) of Manufacturing in China to that in Comoros?
Your response must be concise. 1.63. What is the ratio of the Value added (% of GDP) of Services in China to that in Comoros?
Keep it short and to the point. 0.65. What is the ratio of the Value added (% of GDP) in Agriculture in China to that in Comoros?
Give a very brief answer. 0.52. What is the ratio of the Value added (% of GDP) in Industry in Colombia to that in Comoros?
Offer a terse response. 4.6. What is the ratio of the Value added (% of GDP) in Manufacturing in Colombia to that in Comoros?
Keep it short and to the point. 0.55. What is the ratio of the Value added (% of GDP) in Services in Colombia to that in Comoros?
Make the answer very short. 0.89. What is the ratio of the Value added (% of GDP) in Agriculture in Colombia to that in Comoros?
Give a very brief answer. 1.49. What is the difference between the highest and the second highest Value added (% of GDP) in Industry?
Offer a very short reply. 0.6. What is the difference between the highest and the second highest Value added (% of GDP) of Manufacturing?
Provide a succinct answer. 9.26. What is the difference between the highest and the second highest Value added (% of GDP) in Services?
Keep it short and to the point. 0.87. What is the difference between the highest and the second highest Value added (% of GDP) of Agriculture?
Give a very brief answer. 16.05. What is the difference between the highest and the lowest Value added (% of GDP) in Industry?
Your answer should be very brief. 34.06. What is the difference between the highest and the lowest Value added (% of GDP) in Manufacturing?
Provide a short and direct response. 19.96. What is the difference between the highest and the lowest Value added (% of GDP) in Services?
Ensure brevity in your answer.  18.78. What is the difference between the highest and the lowest Value added (% of GDP) in Agriculture?
Your answer should be very brief. 39.02. 